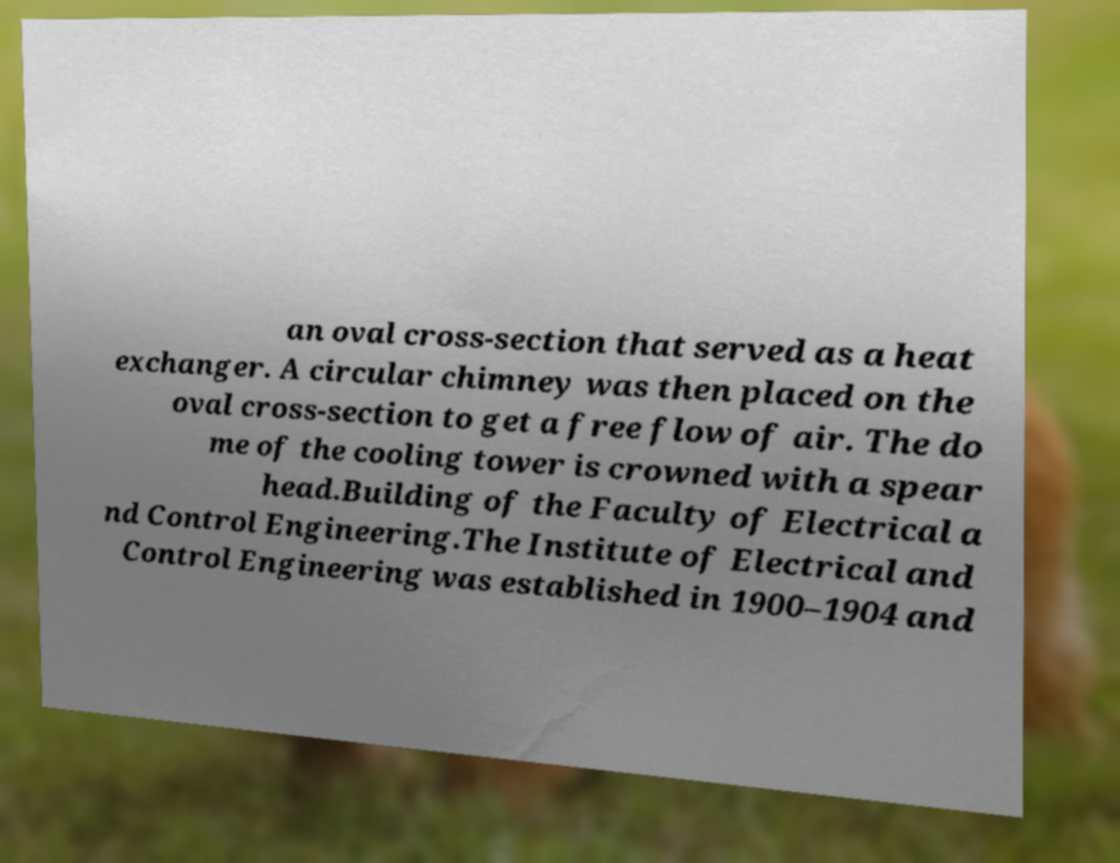Can you read and provide the text displayed in the image?This photo seems to have some interesting text. Can you extract and type it out for me? an oval cross-section that served as a heat exchanger. A circular chimney was then placed on the oval cross-section to get a free flow of air. The do me of the cooling tower is crowned with a spear head.Building of the Faculty of Electrical a nd Control Engineering.The Institute of Electrical and Control Engineering was established in 1900–1904 and 